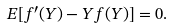Convert formula to latex. <formula><loc_0><loc_0><loc_500><loc_500>E [ f ^ { \prime } ( Y ) - Y f ( Y ) ] = 0 .</formula> 